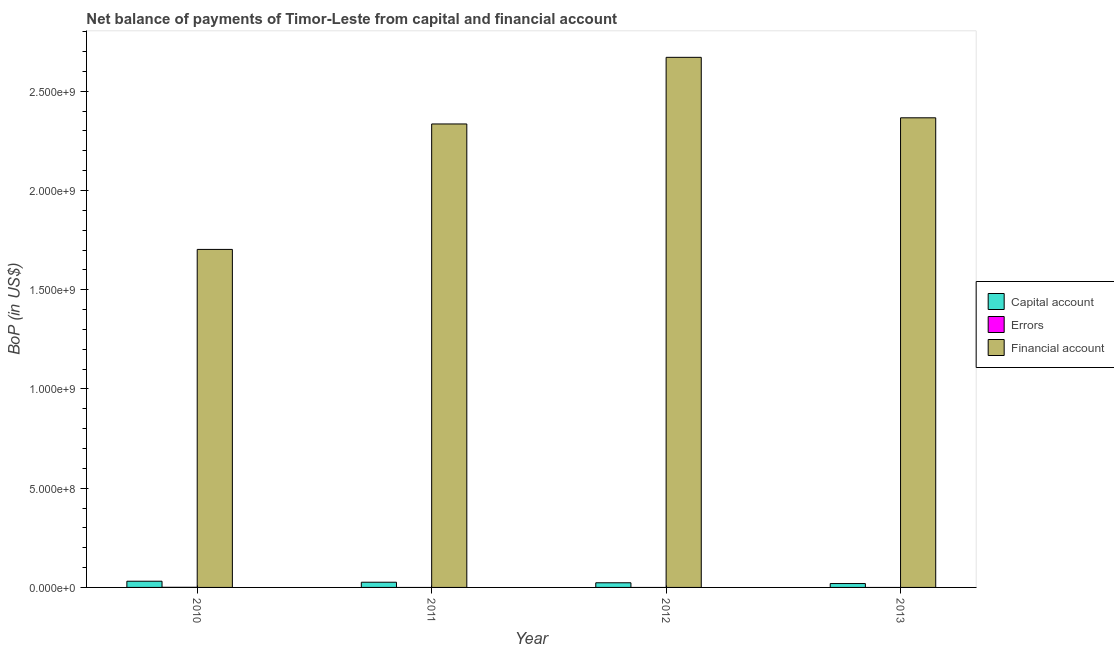What is the label of the 4th group of bars from the left?
Provide a succinct answer. 2013. In how many cases, is the number of bars for a given year not equal to the number of legend labels?
Your answer should be compact. 3. What is the amount of errors in 2012?
Keep it short and to the point. 0. Across all years, what is the maximum amount of financial account?
Ensure brevity in your answer.  2.67e+09. Across all years, what is the minimum amount of errors?
Your answer should be very brief. 0. In which year was the amount of errors maximum?
Give a very brief answer. 2010. What is the total amount of errors in the graph?
Make the answer very short. 5.13e+05. What is the difference between the amount of net capital account in 2010 and that in 2013?
Provide a short and direct response. 1.17e+07. What is the difference between the amount of errors in 2011 and the amount of financial account in 2012?
Your response must be concise. 0. What is the average amount of financial account per year?
Make the answer very short. 2.27e+09. In the year 2011, what is the difference between the amount of financial account and amount of net capital account?
Offer a very short reply. 0. What is the ratio of the amount of financial account in 2010 to that in 2012?
Ensure brevity in your answer.  0.64. Is the difference between the amount of financial account in 2011 and 2012 greater than the difference between the amount of errors in 2011 and 2012?
Your response must be concise. No. What is the difference between the highest and the second highest amount of net capital account?
Offer a terse response. 5.03e+06. What is the difference between the highest and the lowest amount of net capital account?
Your answer should be compact. 1.17e+07. Is it the case that in every year, the sum of the amount of net capital account and amount of errors is greater than the amount of financial account?
Ensure brevity in your answer.  No. How many years are there in the graph?
Offer a very short reply. 4. Are the values on the major ticks of Y-axis written in scientific E-notation?
Offer a very short reply. Yes. How many legend labels are there?
Offer a terse response. 3. How are the legend labels stacked?
Provide a succinct answer. Vertical. What is the title of the graph?
Provide a succinct answer. Net balance of payments of Timor-Leste from capital and financial account. What is the label or title of the Y-axis?
Give a very brief answer. BoP (in US$). What is the BoP (in US$) in Capital account in 2010?
Offer a very short reply. 3.13e+07. What is the BoP (in US$) of Errors in 2010?
Your answer should be compact. 5.13e+05. What is the BoP (in US$) of Financial account in 2010?
Provide a short and direct response. 1.70e+09. What is the BoP (in US$) of Capital account in 2011?
Provide a succinct answer. 2.62e+07. What is the BoP (in US$) in Errors in 2011?
Your answer should be very brief. 0. What is the BoP (in US$) in Financial account in 2011?
Your response must be concise. 2.34e+09. What is the BoP (in US$) of Capital account in 2012?
Make the answer very short. 2.34e+07. What is the BoP (in US$) in Errors in 2012?
Make the answer very short. 0. What is the BoP (in US$) of Financial account in 2012?
Offer a very short reply. 2.67e+09. What is the BoP (in US$) in Capital account in 2013?
Give a very brief answer. 1.95e+07. What is the BoP (in US$) of Errors in 2013?
Provide a succinct answer. 0. What is the BoP (in US$) in Financial account in 2013?
Ensure brevity in your answer.  2.37e+09. Across all years, what is the maximum BoP (in US$) in Capital account?
Your answer should be compact. 3.13e+07. Across all years, what is the maximum BoP (in US$) in Errors?
Give a very brief answer. 5.13e+05. Across all years, what is the maximum BoP (in US$) of Financial account?
Provide a succinct answer. 2.67e+09. Across all years, what is the minimum BoP (in US$) in Capital account?
Ensure brevity in your answer.  1.95e+07. Across all years, what is the minimum BoP (in US$) of Errors?
Offer a very short reply. 0. Across all years, what is the minimum BoP (in US$) of Financial account?
Keep it short and to the point. 1.70e+09. What is the total BoP (in US$) of Capital account in the graph?
Provide a succinct answer. 1.00e+08. What is the total BoP (in US$) in Errors in the graph?
Offer a terse response. 5.13e+05. What is the total BoP (in US$) of Financial account in the graph?
Provide a short and direct response. 9.08e+09. What is the difference between the BoP (in US$) in Capital account in 2010 and that in 2011?
Provide a short and direct response. 5.03e+06. What is the difference between the BoP (in US$) in Financial account in 2010 and that in 2011?
Keep it short and to the point. -6.32e+08. What is the difference between the BoP (in US$) of Capital account in 2010 and that in 2012?
Your answer should be very brief. 7.84e+06. What is the difference between the BoP (in US$) in Financial account in 2010 and that in 2012?
Your answer should be compact. -9.68e+08. What is the difference between the BoP (in US$) in Capital account in 2010 and that in 2013?
Your answer should be compact. 1.17e+07. What is the difference between the BoP (in US$) in Financial account in 2010 and that in 2013?
Provide a succinct answer. -6.63e+08. What is the difference between the BoP (in US$) in Capital account in 2011 and that in 2012?
Your response must be concise. 2.81e+06. What is the difference between the BoP (in US$) of Financial account in 2011 and that in 2012?
Give a very brief answer. -3.36e+08. What is the difference between the BoP (in US$) in Capital account in 2011 and that in 2013?
Provide a short and direct response. 6.70e+06. What is the difference between the BoP (in US$) in Financial account in 2011 and that in 2013?
Provide a short and direct response. -3.10e+07. What is the difference between the BoP (in US$) in Capital account in 2012 and that in 2013?
Offer a terse response. 3.89e+06. What is the difference between the BoP (in US$) in Financial account in 2012 and that in 2013?
Your response must be concise. 3.05e+08. What is the difference between the BoP (in US$) of Capital account in 2010 and the BoP (in US$) of Financial account in 2011?
Ensure brevity in your answer.  -2.30e+09. What is the difference between the BoP (in US$) of Errors in 2010 and the BoP (in US$) of Financial account in 2011?
Offer a terse response. -2.33e+09. What is the difference between the BoP (in US$) of Capital account in 2010 and the BoP (in US$) of Financial account in 2012?
Provide a short and direct response. -2.64e+09. What is the difference between the BoP (in US$) in Errors in 2010 and the BoP (in US$) in Financial account in 2012?
Ensure brevity in your answer.  -2.67e+09. What is the difference between the BoP (in US$) of Capital account in 2010 and the BoP (in US$) of Financial account in 2013?
Offer a very short reply. -2.34e+09. What is the difference between the BoP (in US$) in Errors in 2010 and the BoP (in US$) in Financial account in 2013?
Give a very brief answer. -2.37e+09. What is the difference between the BoP (in US$) in Capital account in 2011 and the BoP (in US$) in Financial account in 2012?
Keep it short and to the point. -2.64e+09. What is the difference between the BoP (in US$) in Capital account in 2011 and the BoP (in US$) in Financial account in 2013?
Your answer should be compact. -2.34e+09. What is the difference between the BoP (in US$) of Capital account in 2012 and the BoP (in US$) of Financial account in 2013?
Offer a terse response. -2.34e+09. What is the average BoP (in US$) in Capital account per year?
Ensure brevity in your answer.  2.51e+07. What is the average BoP (in US$) of Errors per year?
Ensure brevity in your answer.  1.28e+05. What is the average BoP (in US$) in Financial account per year?
Give a very brief answer. 2.27e+09. In the year 2010, what is the difference between the BoP (in US$) of Capital account and BoP (in US$) of Errors?
Your answer should be very brief. 3.07e+07. In the year 2010, what is the difference between the BoP (in US$) of Capital account and BoP (in US$) of Financial account?
Keep it short and to the point. -1.67e+09. In the year 2010, what is the difference between the BoP (in US$) in Errors and BoP (in US$) in Financial account?
Provide a short and direct response. -1.70e+09. In the year 2011, what is the difference between the BoP (in US$) of Capital account and BoP (in US$) of Financial account?
Provide a short and direct response. -2.31e+09. In the year 2012, what is the difference between the BoP (in US$) of Capital account and BoP (in US$) of Financial account?
Your response must be concise. -2.65e+09. In the year 2013, what is the difference between the BoP (in US$) of Capital account and BoP (in US$) of Financial account?
Your response must be concise. -2.35e+09. What is the ratio of the BoP (in US$) in Capital account in 2010 to that in 2011?
Provide a succinct answer. 1.19. What is the ratio of the BoP (in US$) in Financial account in 2010 to that in 2011?
Offer a very short reply. 0.73. What is the ratio of the BoP (in US$) in Capital account in 2010 to that in 2012?
Give a very brief answer. 1.34. What is the ratio of the BoP (in US$) of Financial account in 2010 to that in 2012?
Your answer should be very brief. 0.64. What is the ratio of the BoP (in US$) in Capital account in 2010 to that in 2013?
Provide a short and direct response. 1.6. What is the ratio of the BoP (in US$) in Financial account in 2010 to that in 2013?
Provide a short and direct response. 0.72. What is the ratio of the BoP (in US$) in Capital account in 2011 to that in 2012?
Provide a short and direct response. 1.12. What is the ratio of the BoP (in US$) of Financial account in 2011 to that in 2012?
Your answer should be very brief. 0.87. What is the ratio of the BoP (in US$) in Capital account in 2011 to that in 2013?
Your response must be concise. 1.34. What is the ratio of the BoP (in US$) in Financial account in 2011 to that in 2013?
Give a very brief answer. 0.99. What is the ratio of the BoP (in US$) in Capital account in 2012 to that in 2013?
Give a very brief answer. 1.2. What is the ratio of the BoP (in US$) in Financial account in 2012 to that in 2013?
Your response must be concise. 1.13. What is the difference between the highest and the second highest BoP (in US$) of Capital account?
Your response must be concise. 5.03e+06. What is the difference between the highest and the second highest BoP (in US$) of Financial account?
Your answer should be compact. 3.05e+08. What is the difference between the highest and the lowest BoP (in US$) of Capital account?
Provide a short and direct response. 1.17e+07. What is the difference between the highest and the lowest BoP (in US$) of Errors?
Provide a short and direct response. 5.13e+05. What is the difference between the highest and the lowest BoP (in US$) of Financial account?
Offer a very short reply. 9.68e+08. 